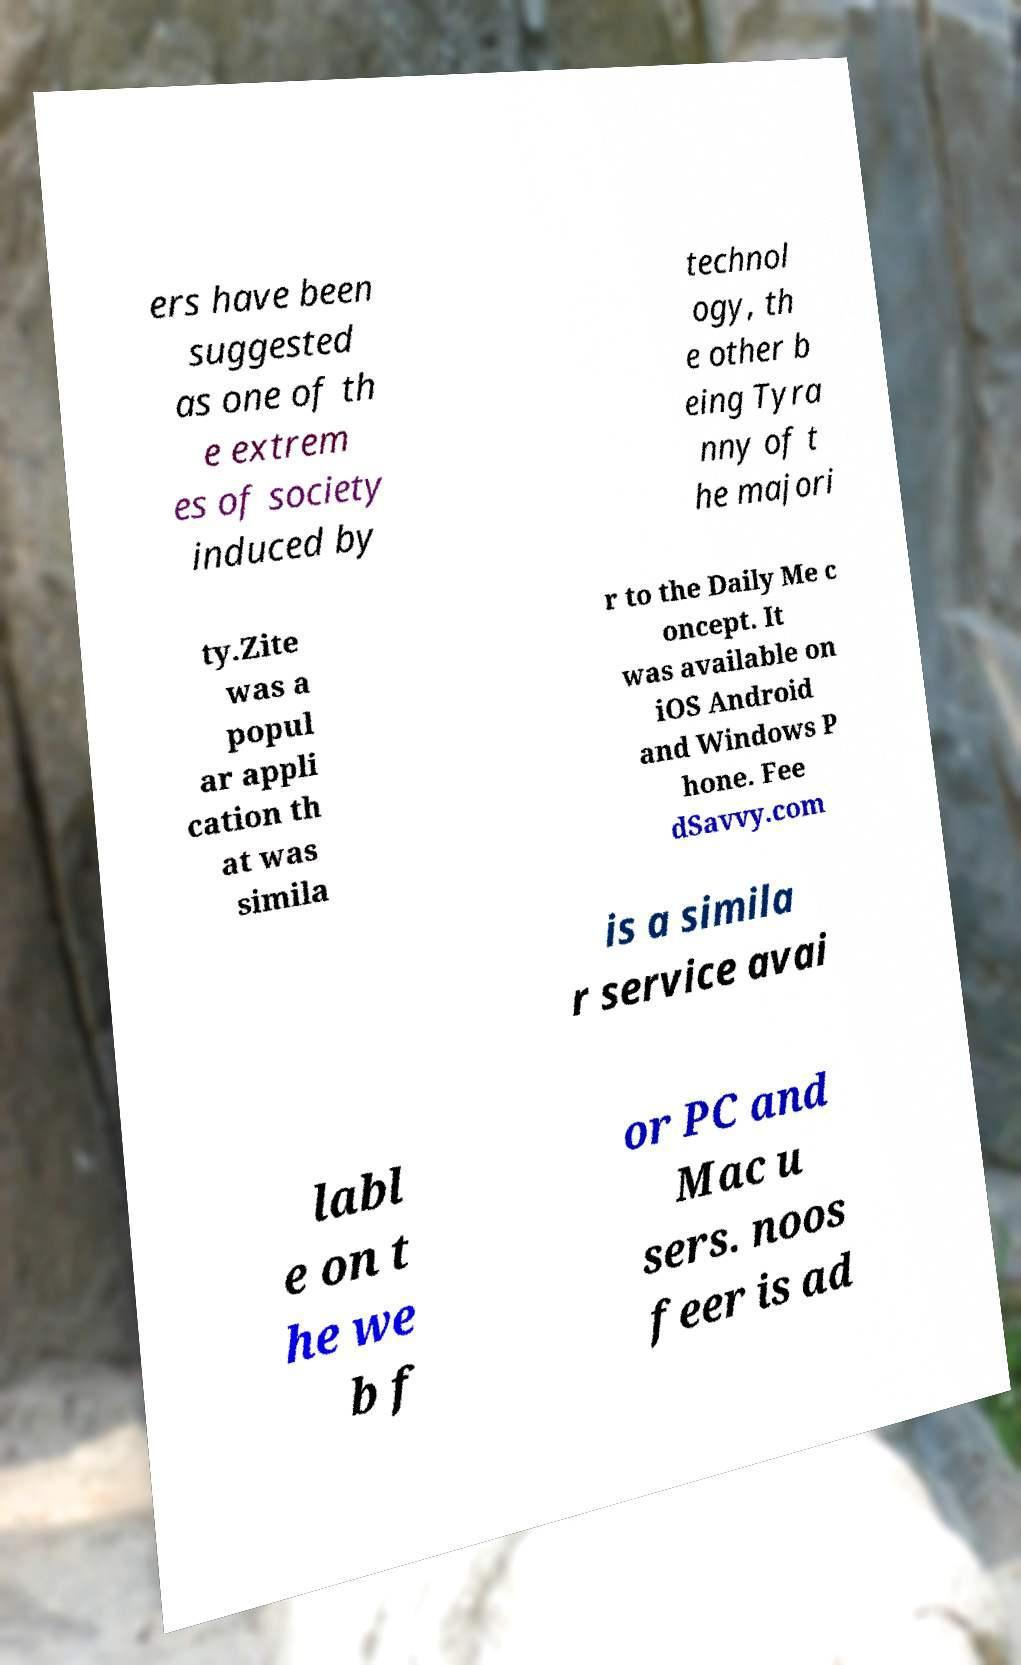I need the written content from this picture converted into text. Can you do that? ers have been suggested as one of th e extrem es of society induced by technol ogy, th e other b eing Tyra nny of t he majori ty.Zite was a popul ar appli cation th at was simila r to the Daily Me c oncept. It was available on iOS Android and Windows P hone. Fee dSavvy.com is a simila r service avai labl e on t he we b f or PC and Mac u sers. noos feer is ad 